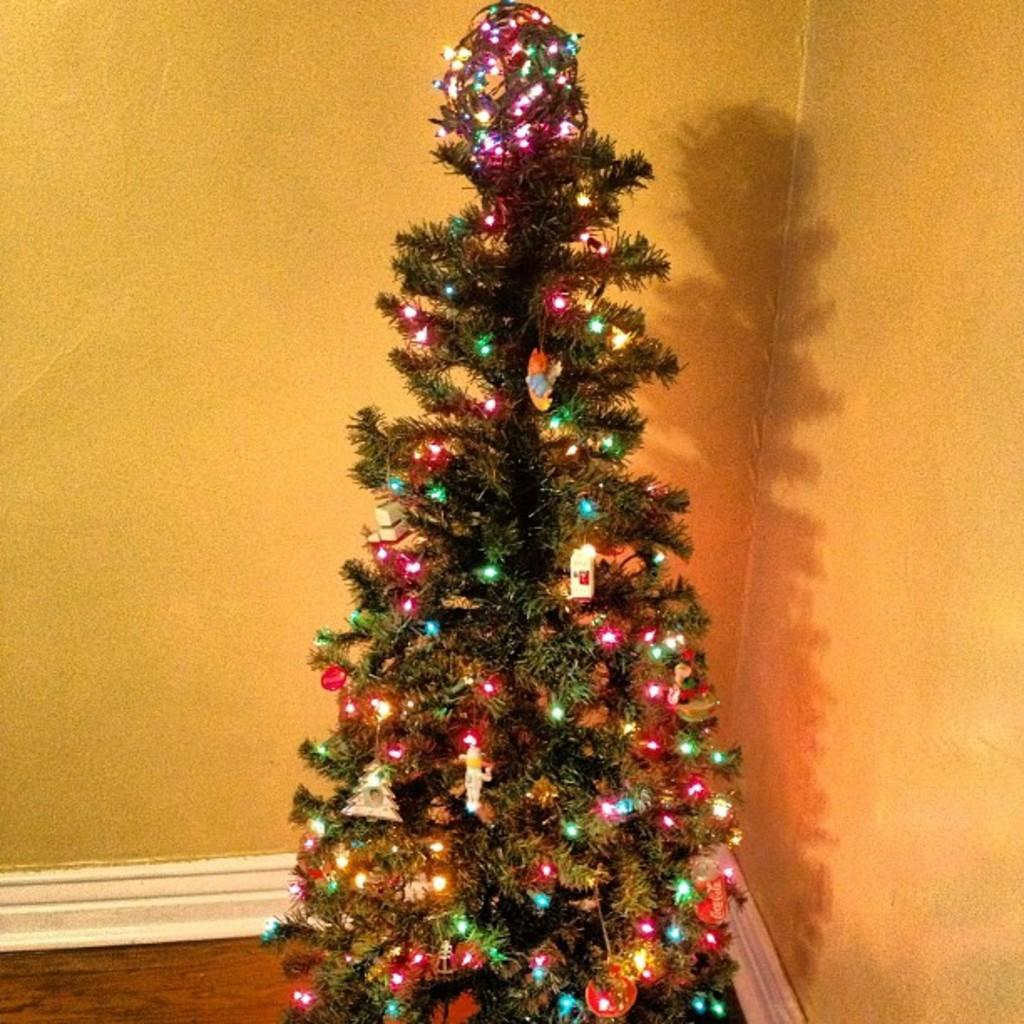What type of tree is visible in the image? There is a decorated Christmas tree in the image. Where is the Christmas tree located? The Christmas tree is on the floor. What can be seen in the background of the image? There are walls visible in the background of the image. What type of note can be seen on the hospital bed in the image? There is no hospital bed or note present in the image; it features a decorated Christmas tree on the floor with walls visible in the background. 